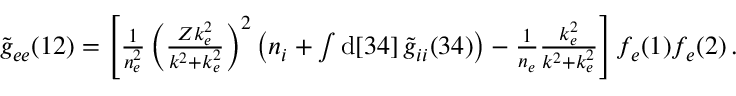<formula> <loc_0><loc_0><loc_500><loc_500>\begin{array} { r } { \widetilde { g } _ { e e } ( 1 2 ) = \left [ \frac { 1 } { n _ { e } ^ { 2 } } \left ( \frac { Z k _ { e } ^ { 2 } } { k ^ { 2 } + k _ { e } ^ { 2 } } \right ) ^ { 2 } \left ( n _ { i } + \int d [ 3 4 ] \, \widetilde { g } _ { i i } ( 3 4 ) \right ) - \frac { 1 } { n _ { e } } \frac { k _ { e } ^ { 2 } } { k ^ { 2 } + k _ { e } ^ { 2 } } \right ] f _ { e } ( 1 ) f _ { e } ( 2 ) \, . } \end{array}</formula> 